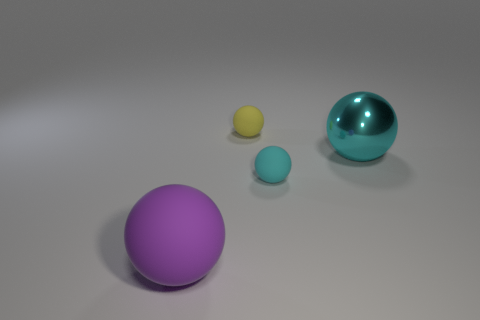There is an object that is behind the large matte ball and in front of the big shiny thing; what is its shape? The object located behind the large matte ball and in front of the big shiny thing is another sphere, demonstrating a smaller size and a distinct turquoise color which differentiates it from the other spherical objects in the scene. 